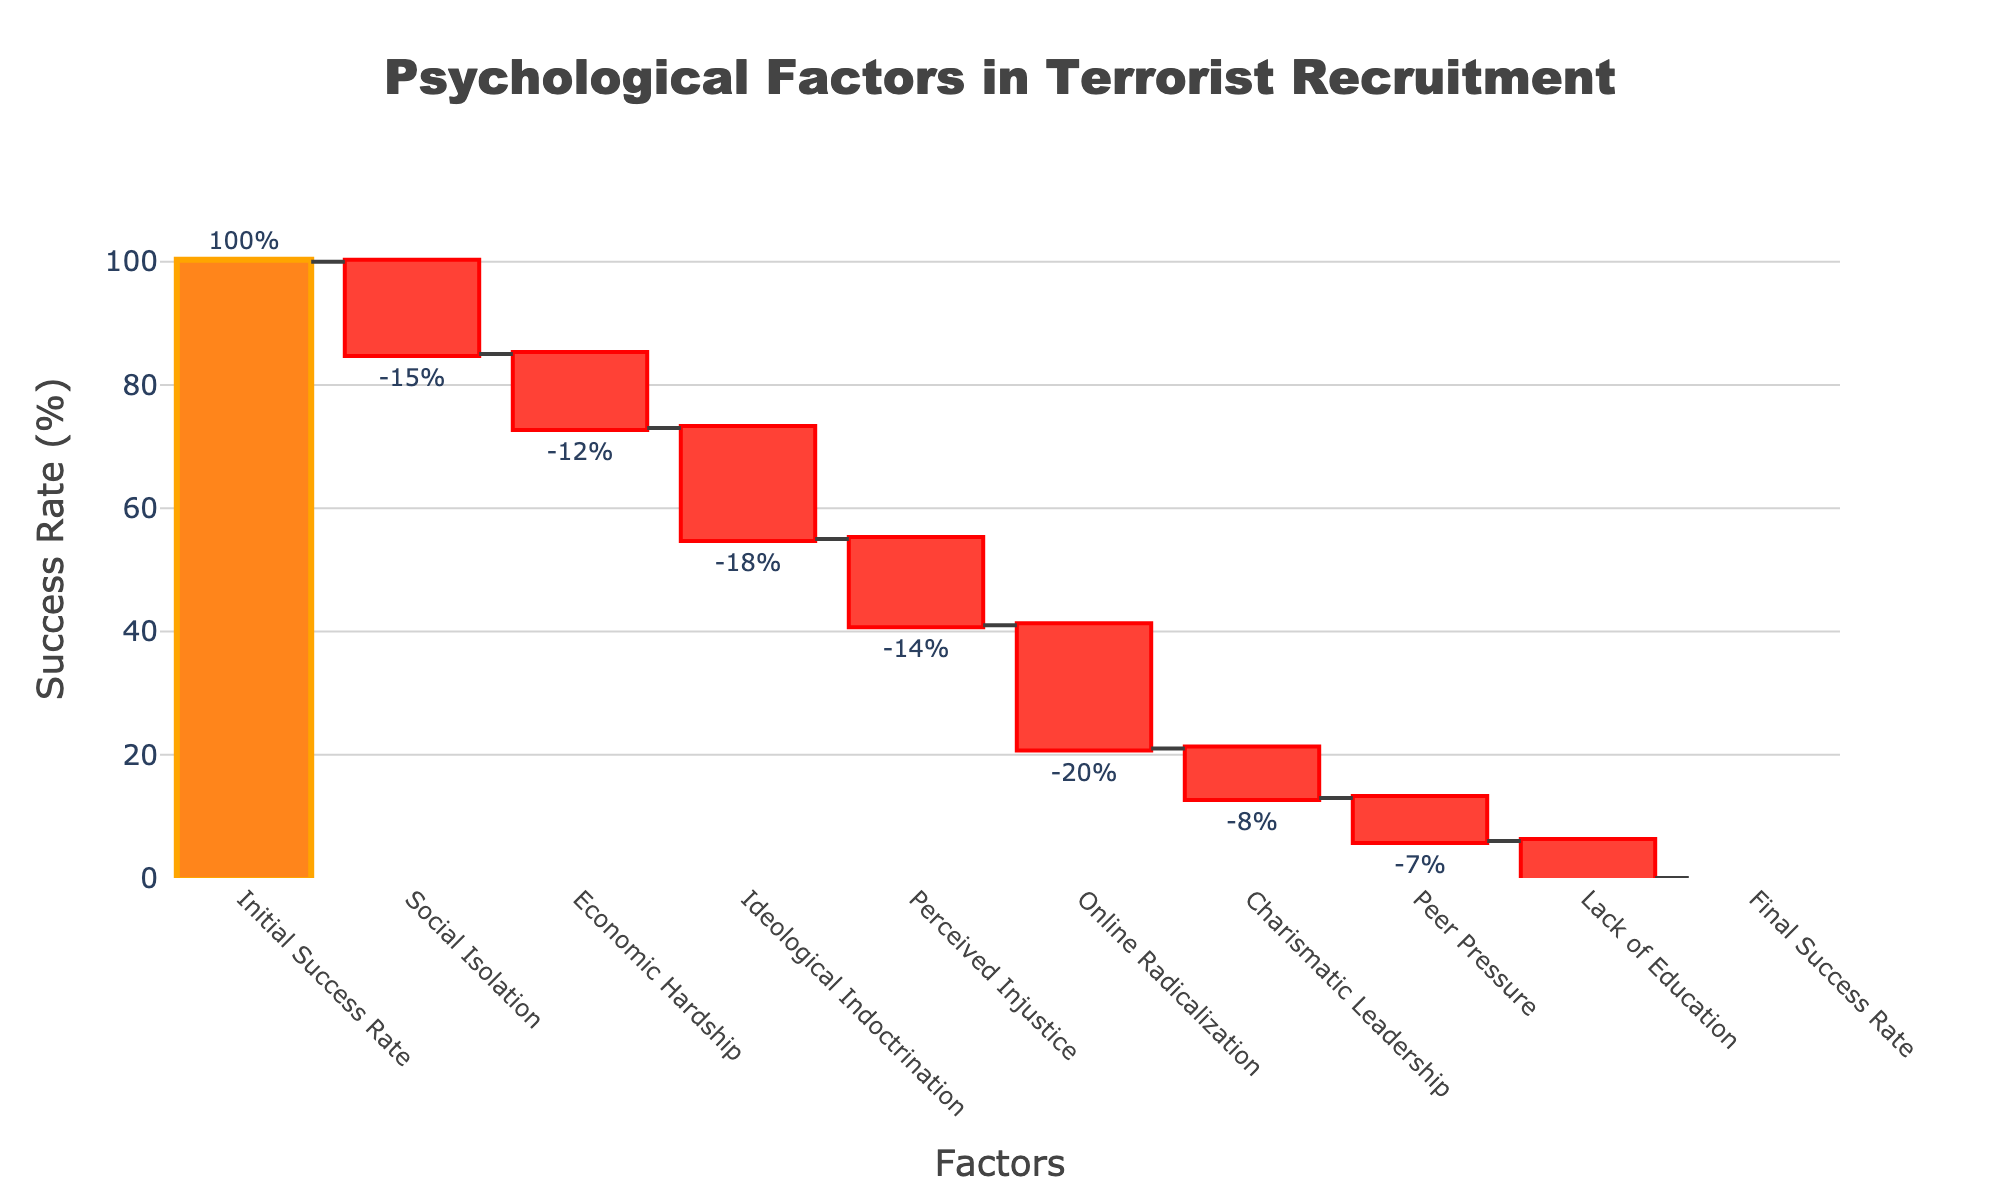What's the title of the chart? The title is located at the top of the chart and is usually the most prominent text. It reads "Psychological Factors in Terrorist Recruitment."
Answer: Psychological Factors in Terrorist Recruitment What is the initial success rate? The initial success rate is the starting value of the chart, labeled as "Initial Success Rate" and plotted at the far left of the chart. The initial success rate is 100%.
Answer: 100% How much does social isolation contribute to the reduction of the recruitment success rate? The contribution of social isolation is shown as a decrease of 15%. This is indicated by a negative value next to "Social Isolation."
Answer: -15% What is the final success rate after all factors are considered? The final success rate is shown at the far right of the chart, labeled as "Final Success Rate" and has a value of 0%.
Answer: 0% Which factor has the highest negative impact on the recruitment success rate? To find the factor with the highest negative impact, look at the value with the largest decrease. "Online Radicalization" has the largest negative value of -20%.
Answer: Online Radicalization By how much does economic hardship reduce the success rate? The reduction due to economic hardship is indicated by a value of -12%.
Answer: -12% What is the combined impact of ideological indoctrination and perceived injustice on the success rate? Add the negative impacts of ideological indoctrination (-18%) and perceived injustice (-14%) together. The combined impact is -18% + -14% = -32%.
Answer: -32% Which factor has the smallest impact on the success rate, and what is its value? To determine the smallest impact, look for the smallest absolute value among the negative factors. "Lack of Education" has the smallest impact at -6%.
Answer: Lack of Education, -6% Does the final success rate match the expected outcome after accounting for all factors? To verify this, sum all the negative contributions and subtract from the initial success rate of 100%. The total negative impact is -100%, which when subtracted from 100% results in 0%, matching the final success rate shown.
Answer: Yes What is the total decrease in success rate due to all factors combined? Summing the negative values: -15% (Social Isolation) - 12% (Economic Hardship) - 18% (Ideological Indoctrination) - 14% (Perceived Injustice) - 20% (Online Radicalization) - 8% (Charismatic Leadership) - 7% (Peer Pressure) - 6% (Lack of Education) equals a total decrease of -100%.
Answer: -100% 